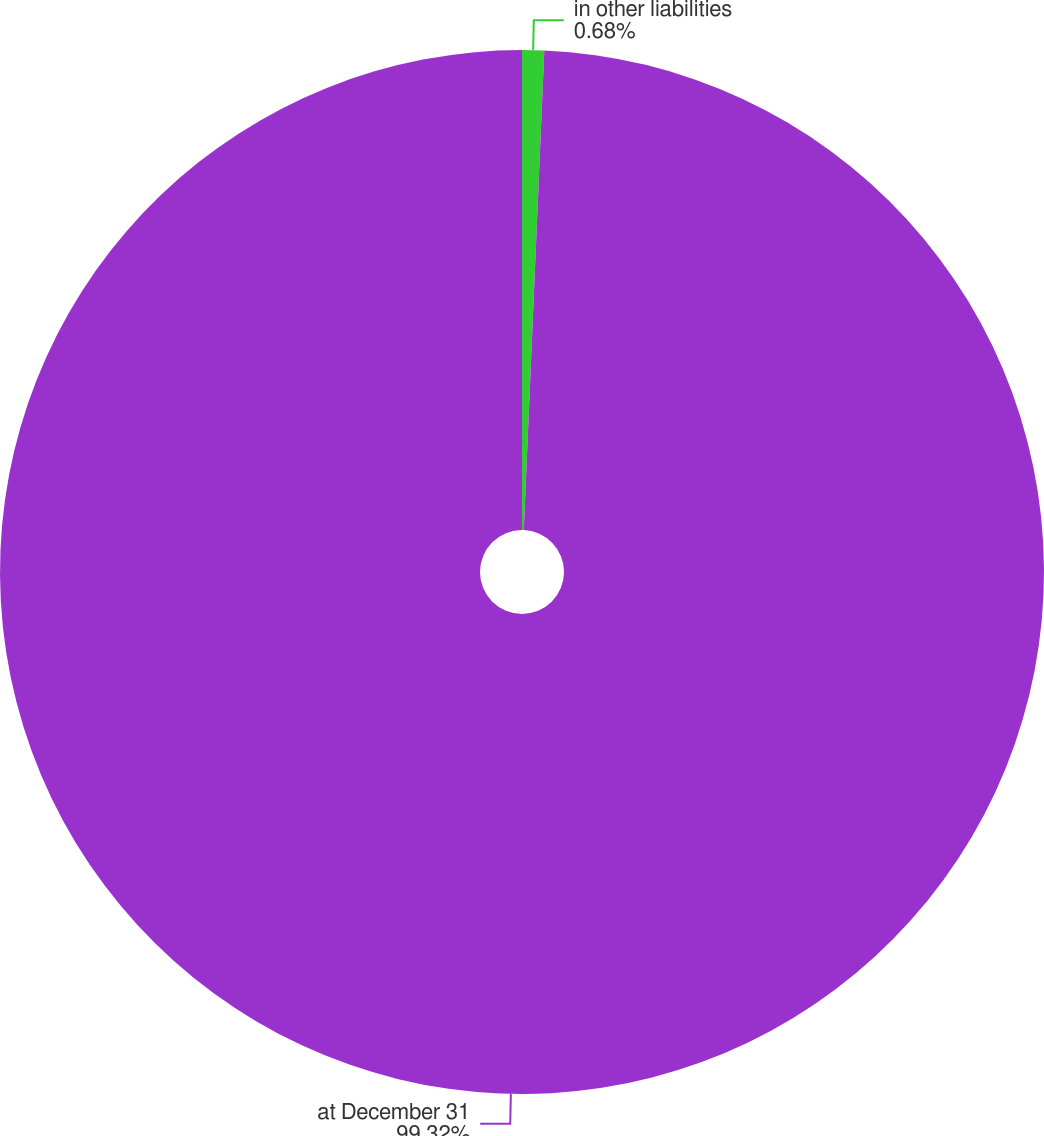Convert chart. <chart><loc_0><loc_0><loc_500><loc_500><pie_chart><fcel>in other liabilities<fcel>at December 31<nl><fcel>0.68%<fcel>99.32%<nl></chart> 